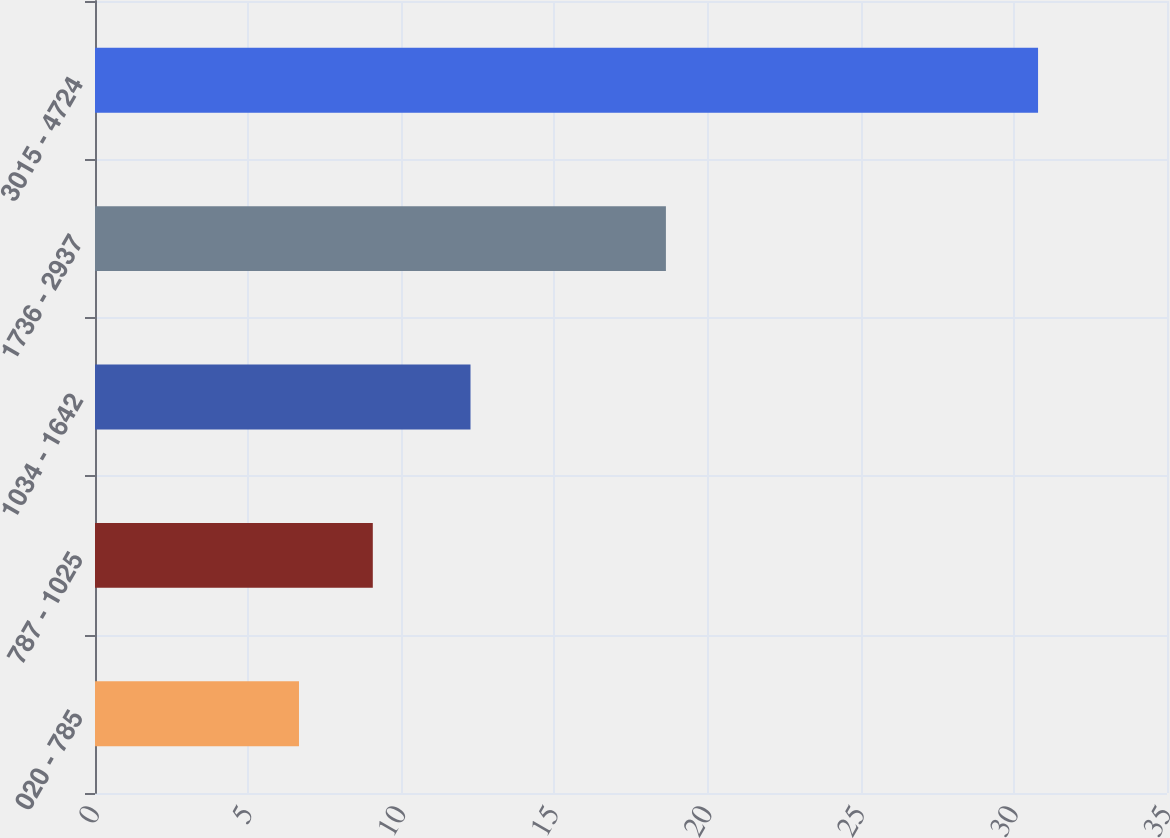Convert chart. <chart><loc_0><loc_0><loc_500><loc_500><bar_chart><fcel>020 - 785<fcel>787 - 1025<fcel>1034 - 1642<fcel>1736 - 2937<fcel>3015 - 4724<nl><fcel>6.66<fcel>9.07<fcel>12.26<fcel>18.64<fcel>30.79<nl></chart> 